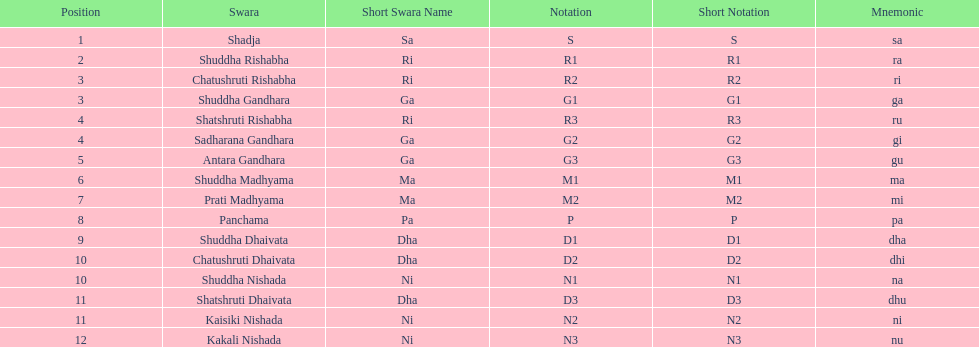What is the name of the swara that comes after panchama? Shuddha Dhaivata. 